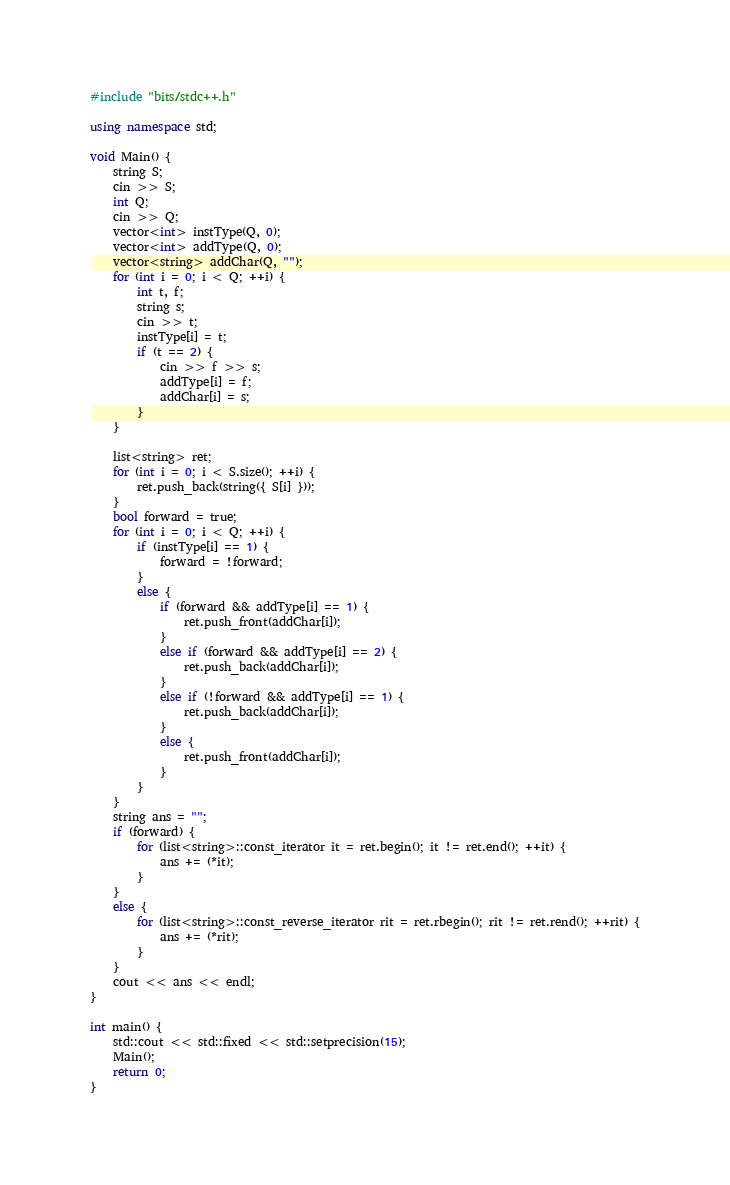Convert code to text. <code><loc_0><loc_0><loc_500><loc_500><_C++_>#include "bits/stdc++.h"

using namespace std;

void Main() {
    string S;
    cin >> S;
    int Q;
    cin >> Q;
    vector<int> instType(Q, 0);
    vector<int> addType(Q, 0);
    vector<string> addChar(Q, "");
    for (int i = 0; i < Q; ++i) {
        int t, f;
        string s;
        cin >> t;
        instType[i] = t;
        if (t == 2) {
            cin >> f >> s;
            addType[i] = f;
            addChar[i] = s;
        }
    }

    list<string> ret;
    for (int i = 0; i < S.size(); ++i) {
        ret.push_back(string({ S[i] }));
    }
    bool forward = true;
    for (int i = 0; i < Q; ++i) {
        if (instType[i] == 1) {
            forward = !forward;
        }
        else {
            if (forward && addType[i] == 1) {
                ret.push_front(addChar[i]);
            }
            else if (forward && addType[i] == 2) {
                ret.push_back(addChar[i]);
            }
            else if (!forward && addType[i] == 1) {
                ret.push_back(addChar[i]);
            }
            else {
                ret.push_front(addChar[i]);
            }
        }
    }
    string ans = "";
    if (forward) {
        for (list<string>::const_iterator it = ret.begin(); it != ret.end(); ++it) {
            ans += (*it);
        }
    }
    else {
        for (list<string>::const_reverse_iterator rit = ret.rbegin(); rit != ret.rend(); ++rit) {
            ans += (*rit);
        }
    }
    cout << ans << endl;
}

int main() {
    std::cout << std::fixed << std::setprecision(15);
    Main();
    return 0;
}
</code> 